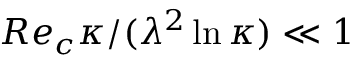Convert formula to latex. <formula><loc_0><loc_0><loc_500><loc_500>R e _ { c } \kappa / ( \lambda ^ { 2 } \ln \kappa ) \ll 1</formula> 